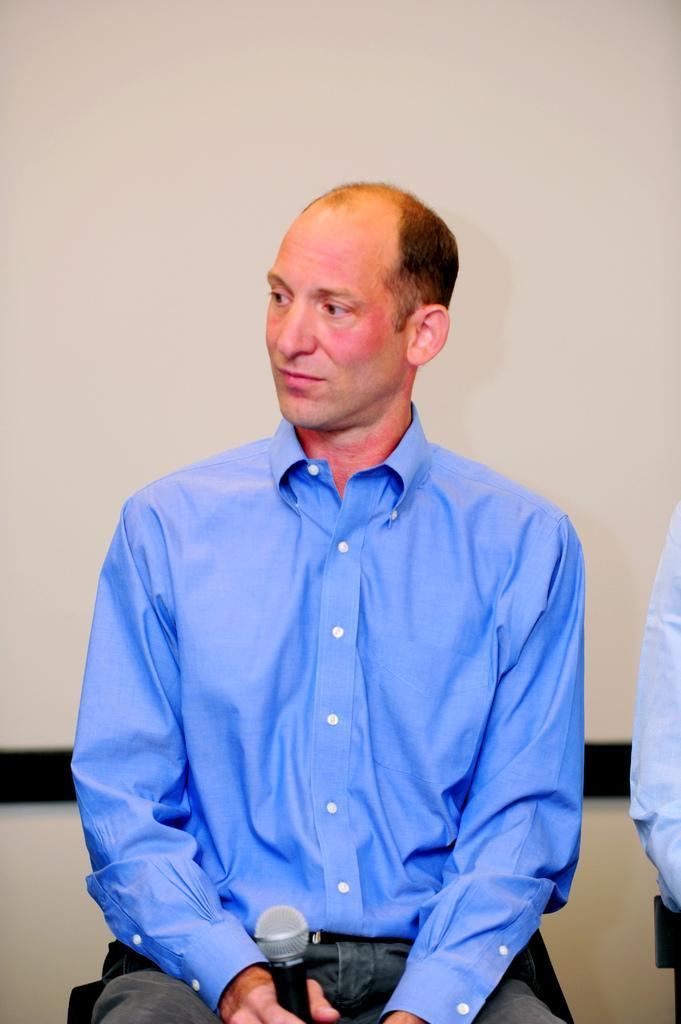Describe this image in one or two sentences. In this picture there is a man sitting and holding a microphone. In the background of the image we can see wall. On the left side of the image we can see cloth. 